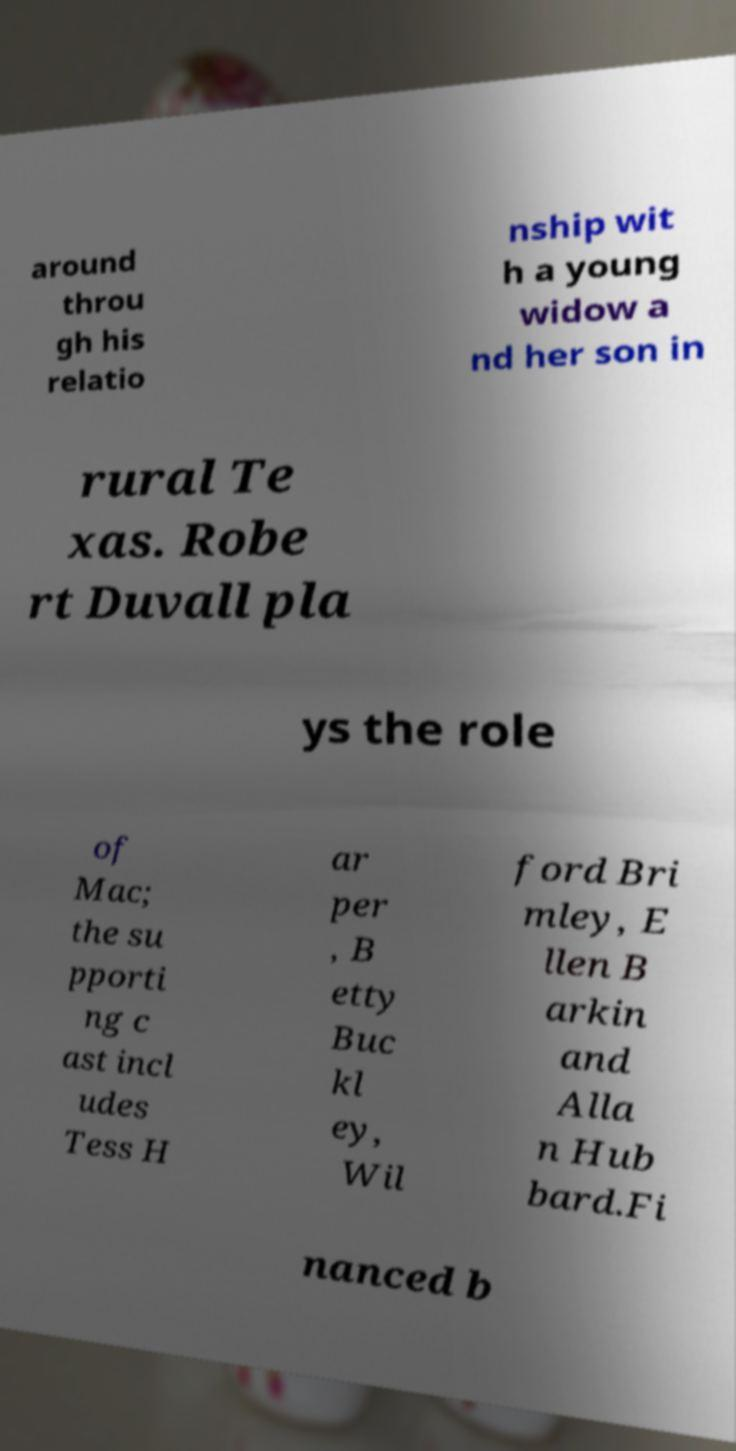For documentation purposes, I need the text within this image transcribed. Could you provide that? around throu gh his relatio nship wit h a young widow a nd her son in rural Te xas. Robe rt Duvall pla ys the role of Mac; the su pporti ng c ast incl udes Tess H ar per , B etty Buc kl ey, Wil ford Bri mley, E llen B arkin and Alla n Hub bard.Fi nanced b 